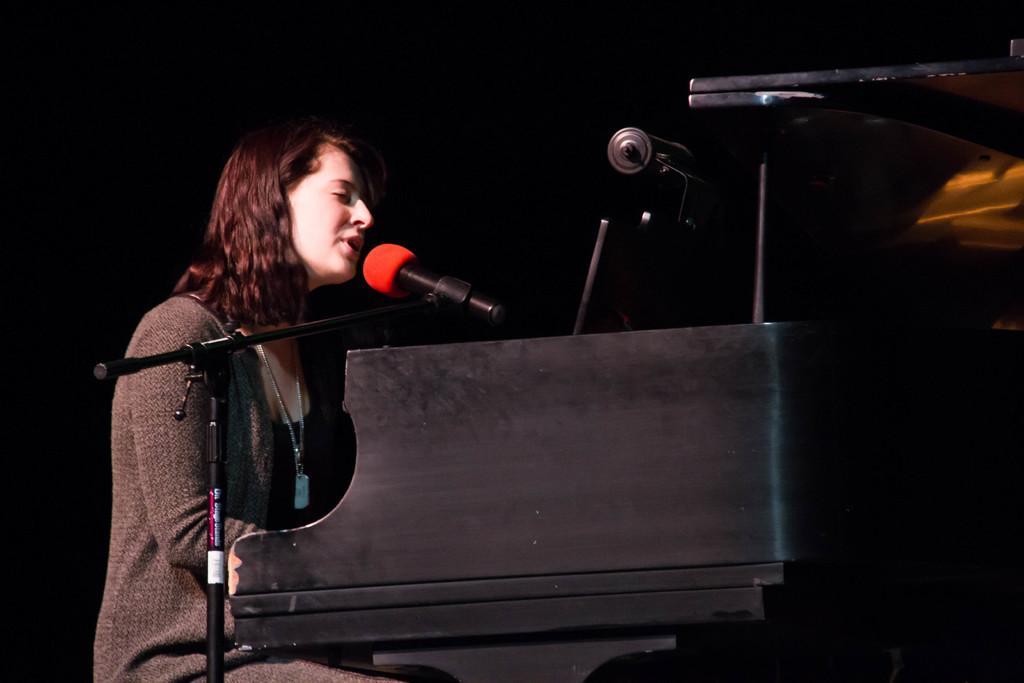Could you give a brief overview of what you see in this image? In this image we can see a person sitting on the seating stool and musical instrument and a mic are placed in front of her. 